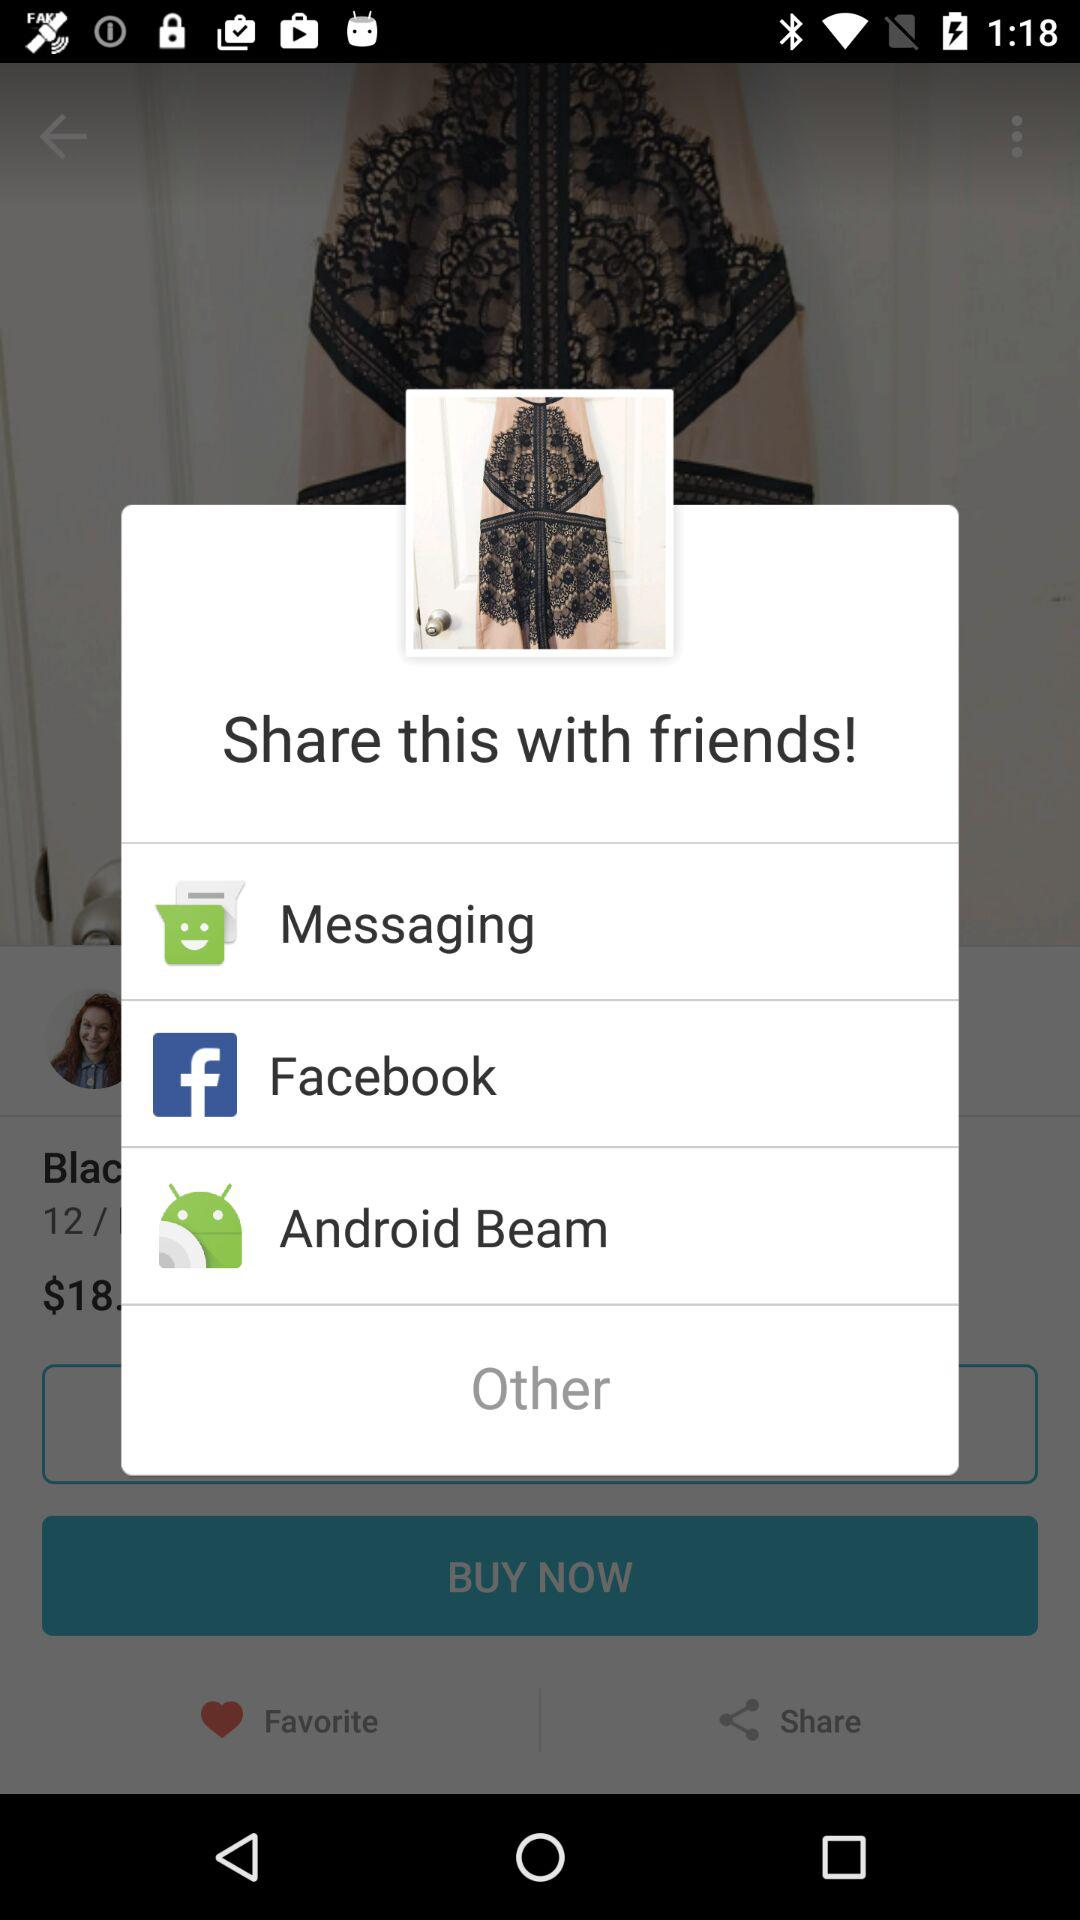With whom can I share this? You can share this with your friends. 